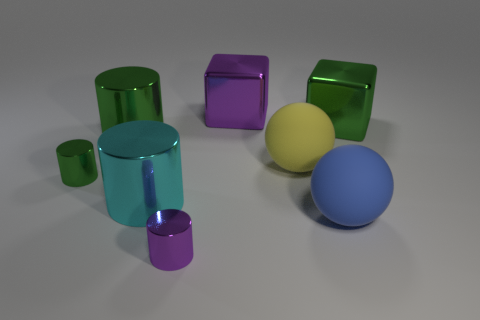There is a large rubber object that is behind the small green cylinder; what color is it?
Make the answer very short. Yellow. What number of rubber objects are big green objects or balls?
Provide a succinct answer. 2. Are there any blue matte spheres to the right of the cube to the right of the big ball that is on the right side of the big yellow rubber thing?
Offer a terse response. No. How many tiny metallic things are in front of the big blue sphere?
Ensure brevity in your answer.  1. What number of large things are either metallic objects or green rubber spheres?
Provide a short and direct response. 4. There is a small object behind the large blue object; what shape is it?
Your answer should be very brief. Cylinder. Do the purple object behind the large blue sphere and the cylinder that is on the left side of the large green cylinder have the same size?
Your answer should be very brief. No. Are there more yellow rubber things that are left of the purple metallic cylinder than tiny purple metallic cylinders on the right side of the big purple cube?
Offer a very short reply. No. Is there a large purple object made of the same material as the tiny purple cylinder?
Your response must be concise. Yes. There is a large thing that is both right of the yellow ball and behind the blue matte thing; what is its material?
Make the answer very short. Metal. 